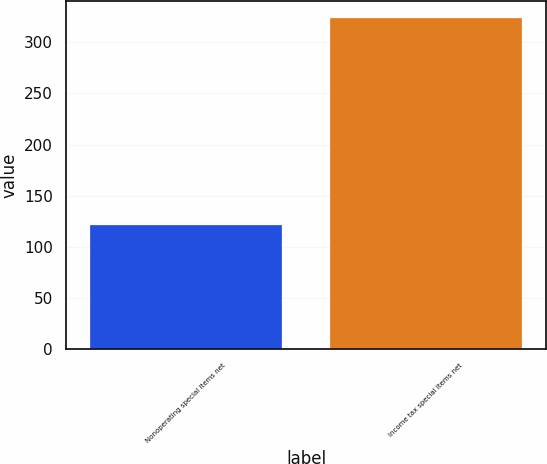<chart> <loc_0><loc_0><loc_500><loc_500><bar_chart><fcel>Nonoperating special items net<fcel>Income tax special items net<nl><fcel>121<fcel>324<nl></chart> 